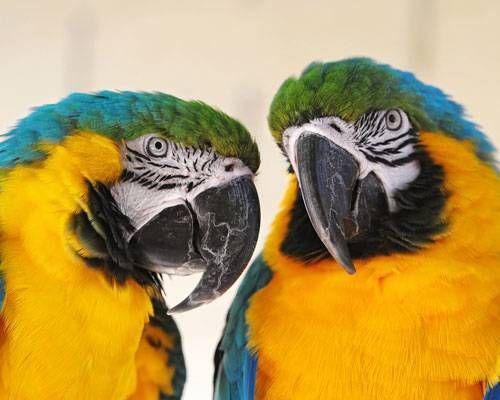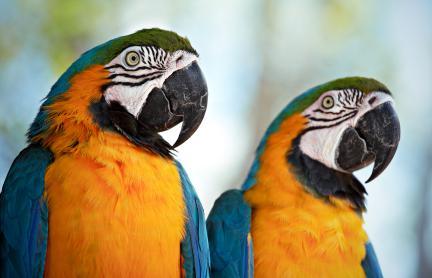The first image is the image on the left, the second image is the image on the right. Analyze the images presented: Is the assertion "Exactly four parrots are shown, two in each image, all of them with the same eye design and gold chests, one pair looking at each other, while one pair looks in the same direction." valid? Answer yes or no. Yes. The first image is the image on the left, the second image is the image on the right. Evaluate the accuracy of this statement regarding the images: "One image includes a red-feathered parrot along with a blue-and-yellow parrot.". Is it true? Answer yes or no. No. 